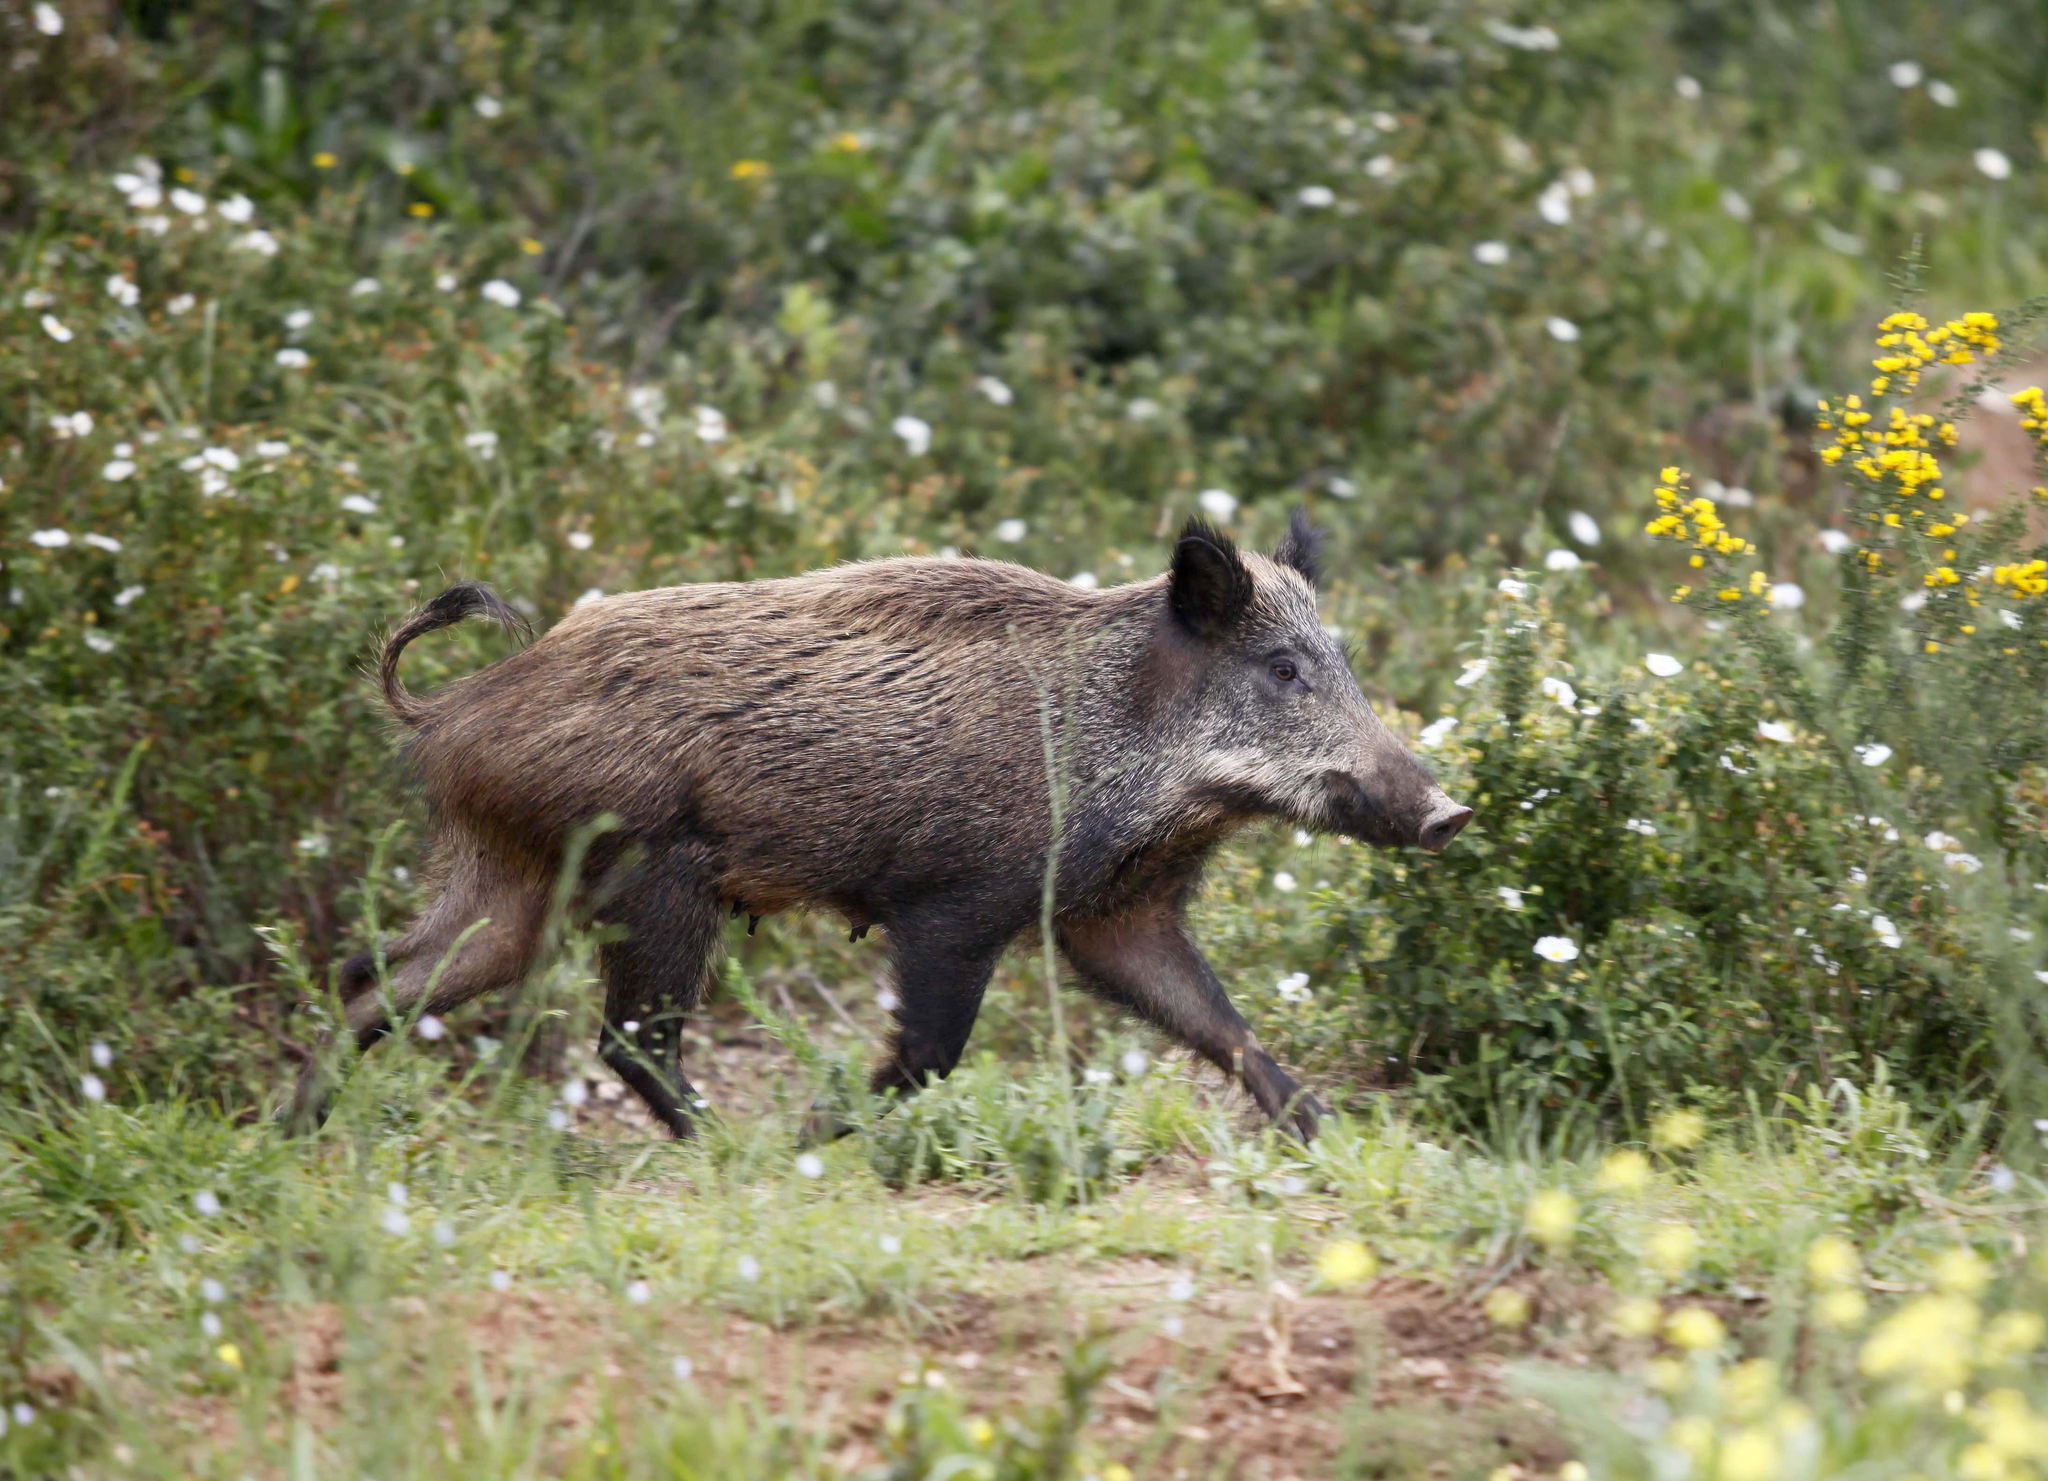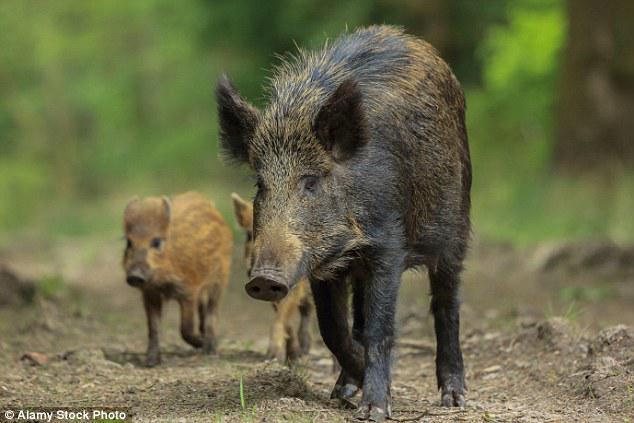The first image is the image on the left, the second image is the image on the right. Analyze the images presented: Is the assertion "One image shows a single adult pig in profile, and the other image includes at least one adult wild pig with two smaller piglets." valid? Answer yes or no. Yes. The first image is the image on the left, the second image is the image on the right. For the images shown, is this caption "There are two hogs in total." true? Answer yes or no. No. 